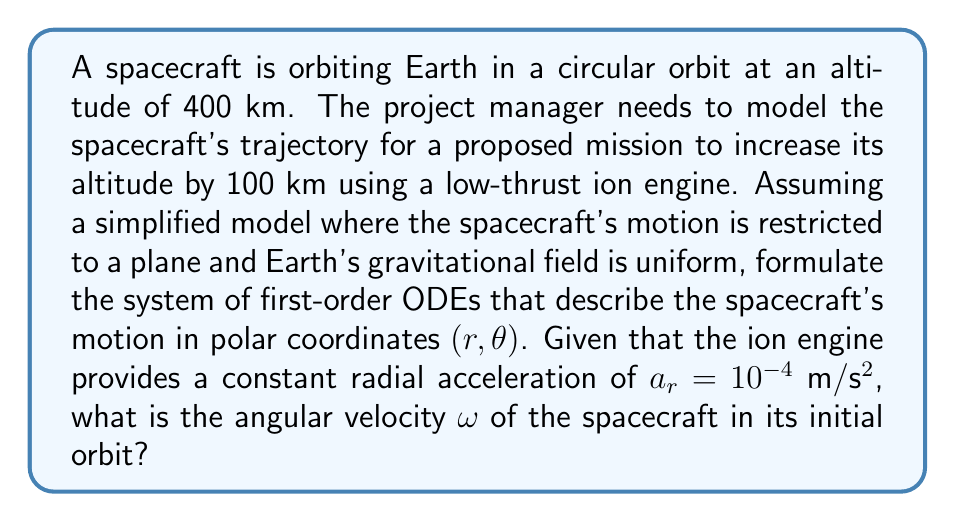Teach me how to tackle this problem. To solve this problem, we'll follow these steps:

1) First, let's formulate the system of ODEs for the spacecraft's motion in polar coordinates:

   $$\frac{d^2r}{dt^2} - r\left(\frac{d\theta}{dt}\right)^2 = -\frac{GM}{r^2} + a_r$$
   $$\frac{d}{dt}\left(r^2\frac{d\theta}{dt}\right) = 0$$

   Where $G$ is the gravitational constant, $M$ is the mass of Earth, and $a_r$ is the radial acceleration from the ion engine.

2) To convert these to first-order ODEs, we can introduce new variables:
   Let $u = \frac{dr}{dt}$ and $v = \frac{d\theta}{dt}$

   Then our system becomes:
   $$\frac{dr}{dt} = u$$
   $$\frac{d\theta}{dt} = v$$
   $$\frac{du}{dt} = rv^2 - \frac{GM}{r^2} + a_r$$
   $$\frac{dv}{dt} = -\frac{2uv}{r}$$

3) Now, to find the angular velocity in the initial orbit, we need to use the fact that the orbit is circular. In a circular orbit:
   
   $$\frac{GM}{r^2} = r\omega^2$$

   Where $\omega$ is the angular velocity.

4) The radius $r$ is the sum of Earth's radius and the orbital altitude:
   
   $r = 6371 \text{ km} + 400 \text{ km} = 6771 \text{ km} = 6,771,000 \text{ m}$

5) We can now solve for $\omega$:

   $$\omega = \sqrt{\frac{GM}{r^3}}$$

6) Using the values:
   $G = 6.674 \times 10^{-11} \text{ m}^3\text{kg}^{-1}\text{s}^{-2}$
   $M = 5.972 \times 10^{24} \text{ kg}$
   $r = 6,771,000 \text{ m}$

   We can calculate:

   $$\omega = \sqrt{\frac{(6.674 \times 10^{-11})(5.972 \times 10^{24})}{(6,771,000)^3}} \approx 0.001132 \text{ rad/s}$$
Answer: The angular velocity of the spacecraft in its initial orbit is approximately $0.001132 \text{ rad/s}$. 